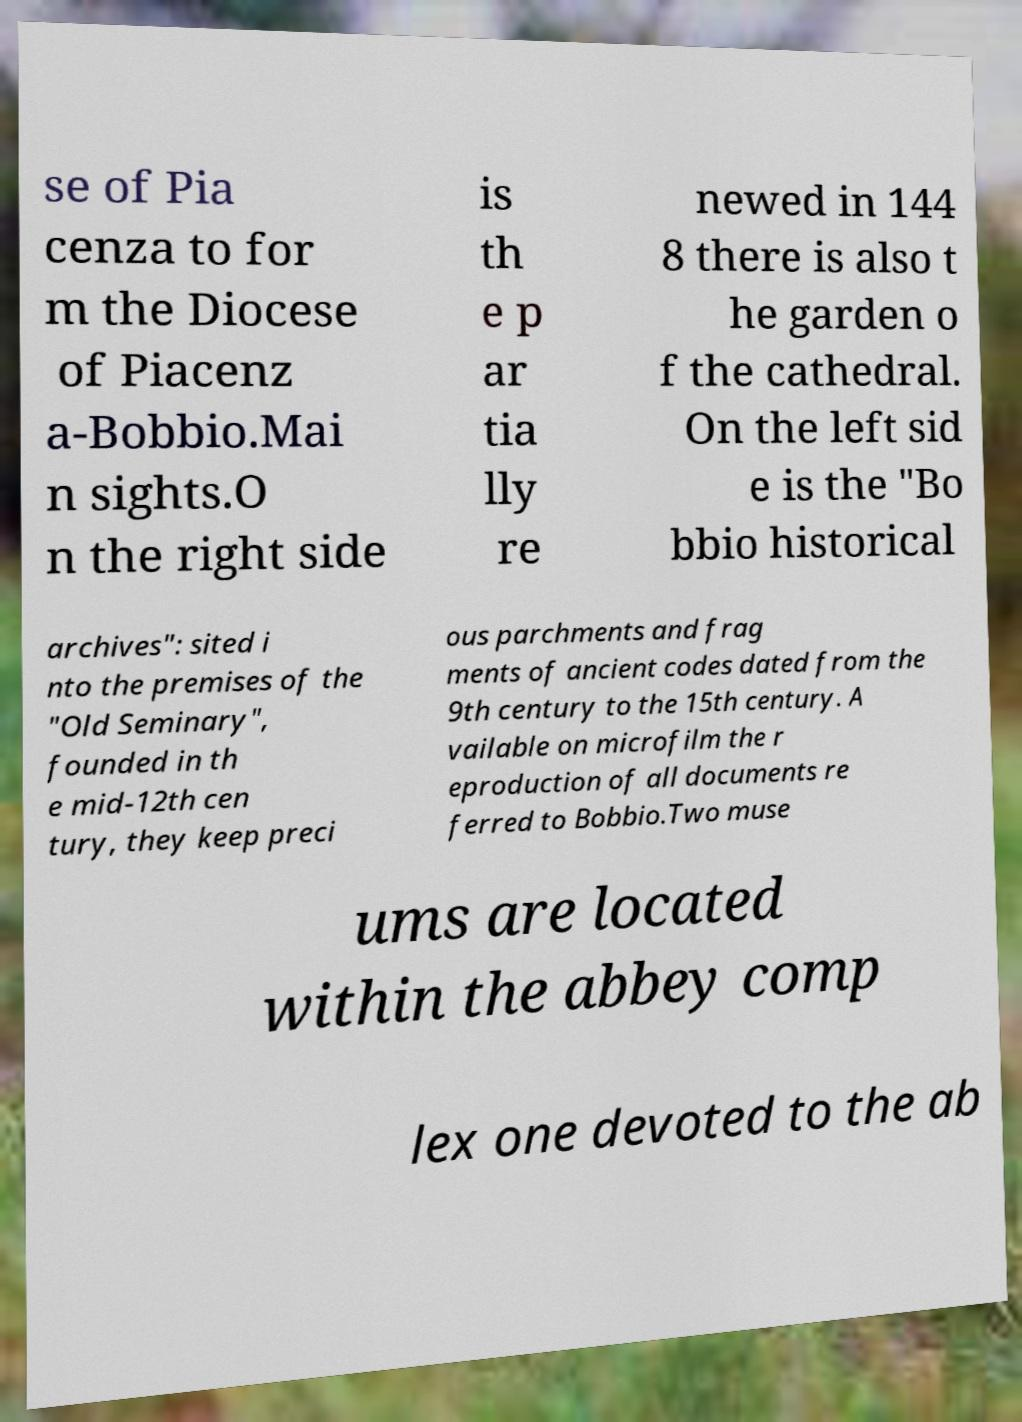What messages or text are displayed in this image? I need them in a readable, typed format. se of Pia cenza to for m the Diocese of Piacenz a-Bobbio.Mai n sights.O n the right side is th e p ar tia lly re newed in 144 8 there is also t he garden o f the cathedral. On the left sid e is the "Bo bbio historical archives": sited i nto the premises of the "Old Seminary", founded in th e mid-12th cen tury, they keep preci ous parchments and frag ments of ancient codes dated from the 9th century to the 15th century. A vailable on microfilm the r eproduction of all documents re ferred to Bobbio.Two muse ums are located within the abbey comp lex one devoted to the ab 